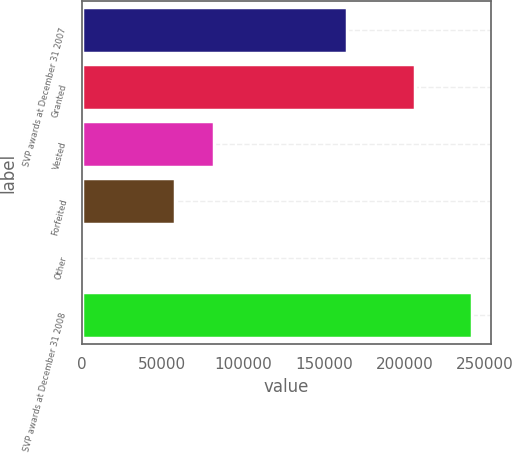Convert chart to OTSL. <chart><loc_0><loc_0><loc_500><loc_500><bar_chart><fcel>SVP awards at December 31 2007<fcel>Granted<fcel>Vested<fcel>Forfeited<fcel>Other<fcel>SVP awards at December 31 2008<nl><fcel>164180<fcel>206578<fcel>81966<fcel>57835<fcel>383<fcel>241693<nl></chart> 